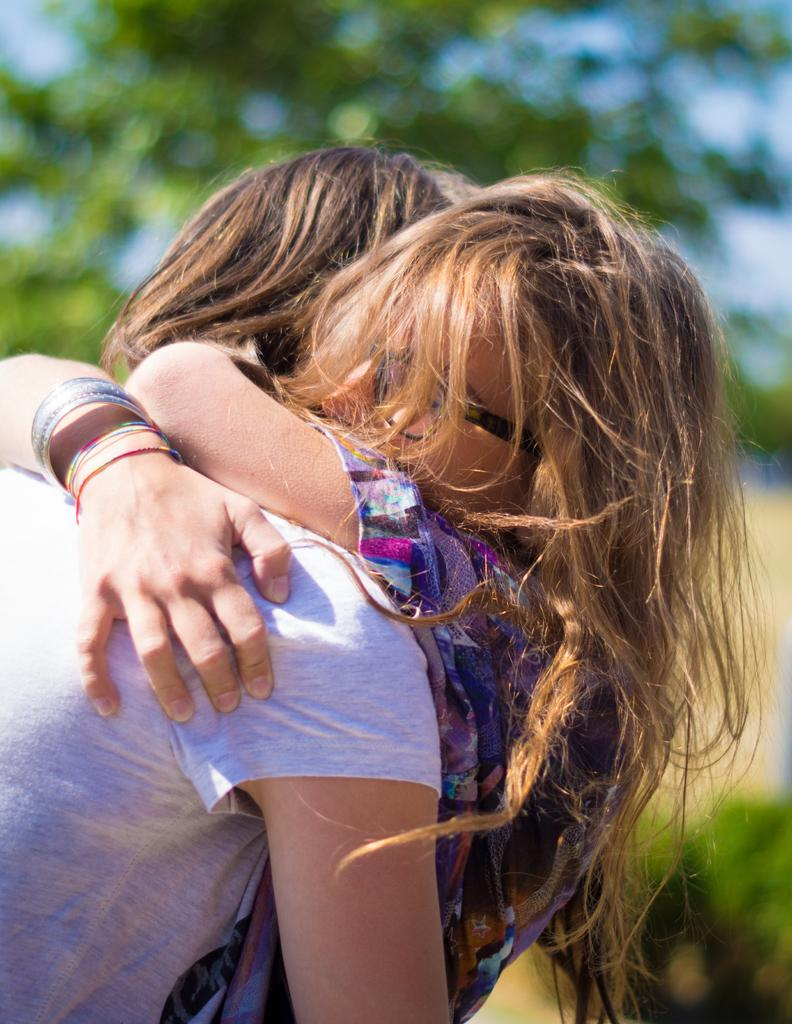How many people are in the image? There are two persons in the image. What are the two persons doing in the image? The two persons are hugging each other. Can you describe any accessories worn by the persons in the image? One person is wearing bangles, and the other person is wearing specs. What is the color and appearance of the background in the image? The background of the image is green and blurred. What type of paper is being used by the person with the throat problem in the image? There is no indication of a throat problem or paper in the image. 